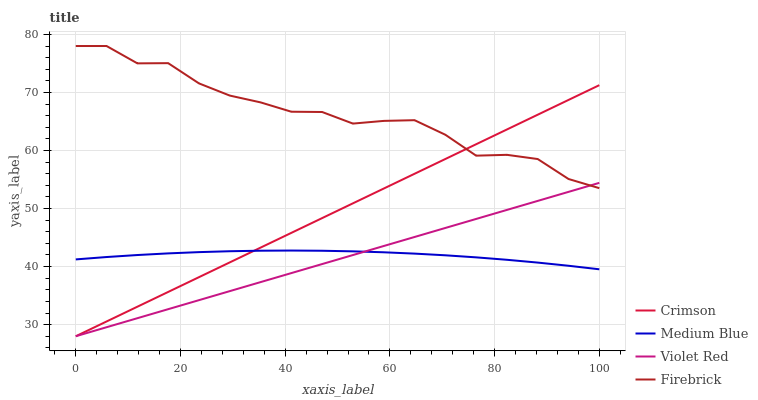Does Violet Red have the minimum area under the curve?
Answer yes or no. Yes. Does Firebrick have the maximum area under the curve?
Answer yes or no. Yes. Does Medium Blue have the minimum area under the curve?
Answer yes or no. No. Does Medium Blue have the maximum area under the curve?
Answer yes or no. No. Is Crimson the smoothest?
Answer yes or no. Yes. Is Firebrick the roughest?
Answer yes or no. Yes. Is Violet Red the smoothest?
Answer yes or no. No. Is Violet Red the roughest?
Answer yes or no. No. Does Crimson have the lowest value?
Answer yes or no. Yes. Does Medium Blue have the lowest value?
Answer yes or no. No. Does Firebrick have the highest value?
Answer yes or no. Yes. Does Violet Red have the highest value?
Answer yes or no. No. Is Medium Blue less than Firebrick?
Answer yes or no. Yes. Is Firebrick greater than Medium Blue?
Answer yes or no. Yes. Does Violet Red intersect Crimson?
Answer yes or no. Yes. Is Violet Red less than Crimson?
Answer yes or no. No. Is Violet Red greater than Crimson?
Answer yes or no. No. Does Medium Blue intersect Firebrick?
Answer yes or no. No. 